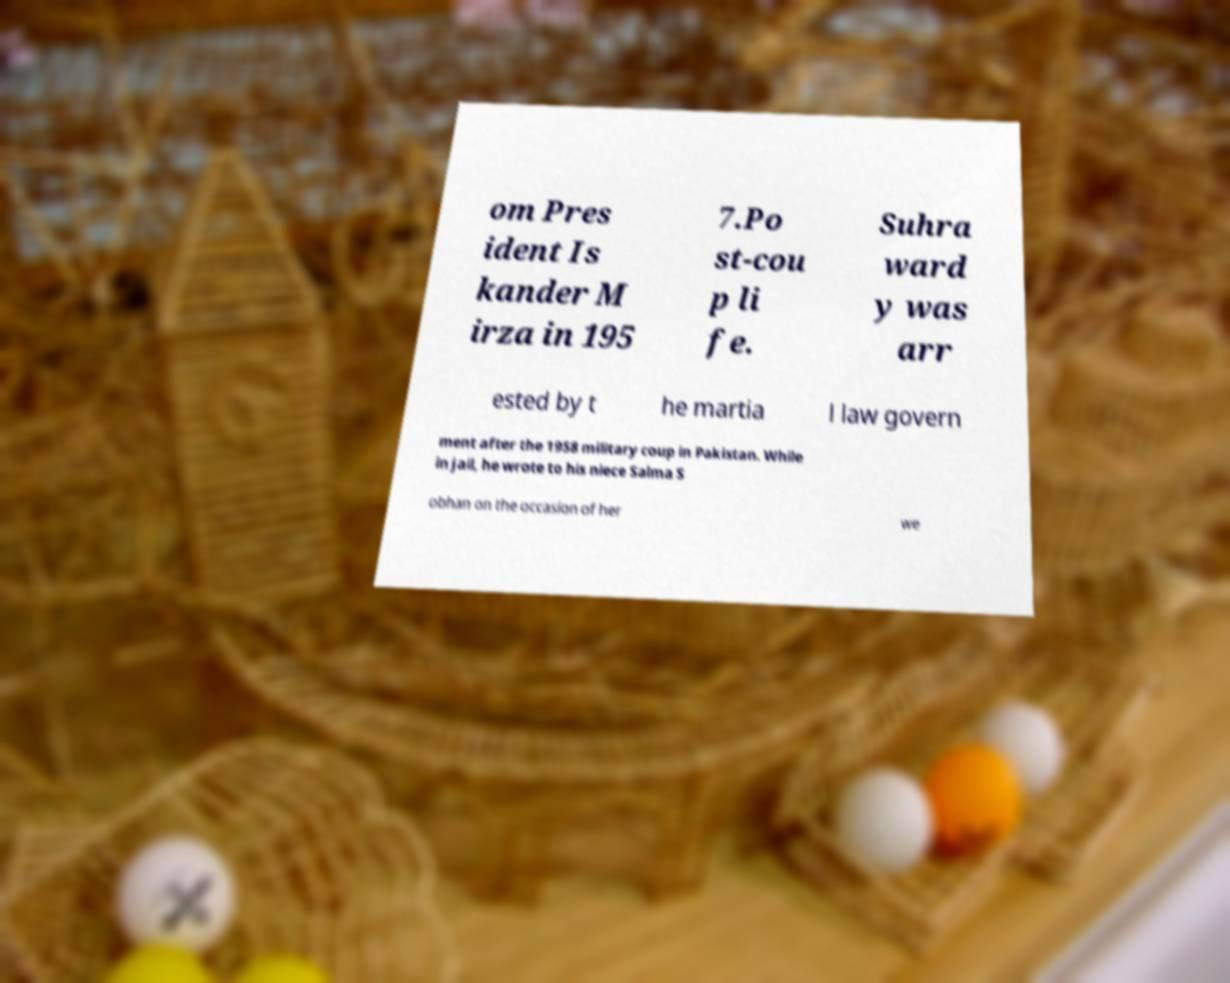What messages or text are displayed in this image? I need them in a readable, typed format. om Pres ident Is kander M irza in 195 7.Po st-cou p li fe. Suhra ward y was arr ested by t he martia l law govern ment after the 1958 military coup in Pakistan. While in jail, he wrote to his niece Salma S obhan on the occasion of her we 